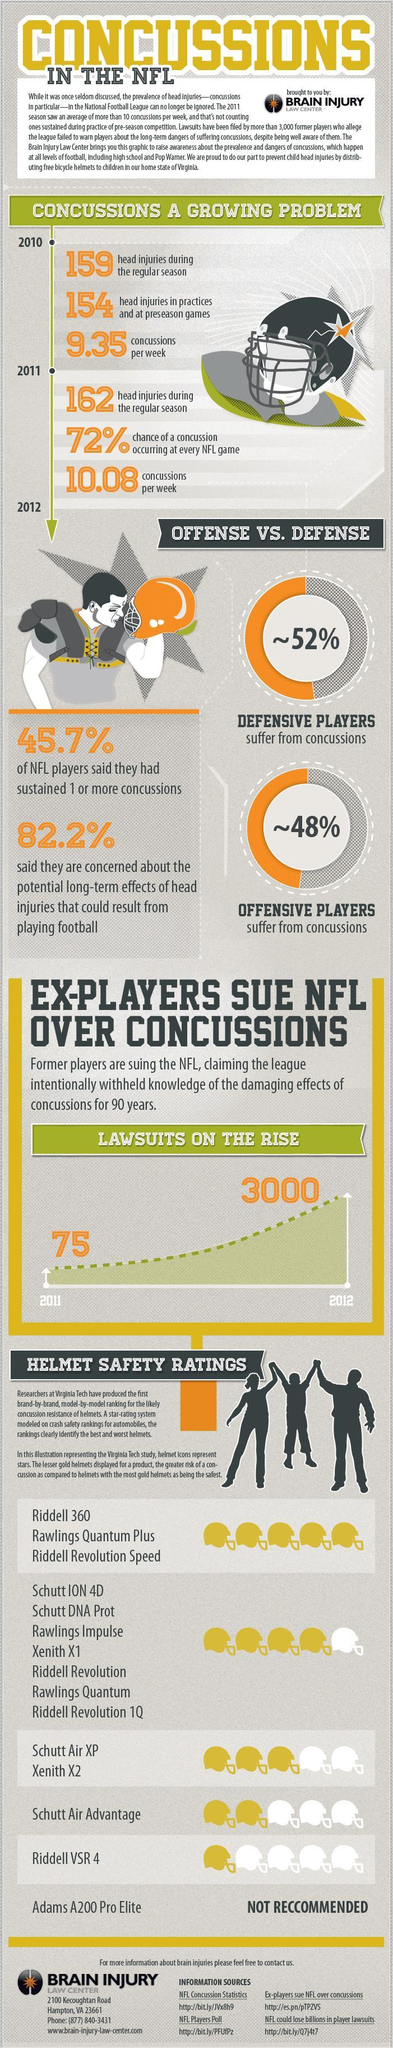what is the safety rating for Schutt Air XP Xenith X2 out of 5?
Answer the question with a short phrase. 3 what is the increase in number of lawsuits in the span of one year from 2011 to 2012? 2925 how many different types of helmets are given in the safety helmet rating list? 6 in which year number of concussions per week were higher - 2010 or 2011? 2011 what is the safety rating for Schutt Air Advantage out of 5? 2 what is the total number of head injuries during regular season in 2010 and 2011 combined? 321 what is the safety rating for "Riddell VSR 4" out of 5? 1 which kind of players are more likely to suffer from concussions? defensive 